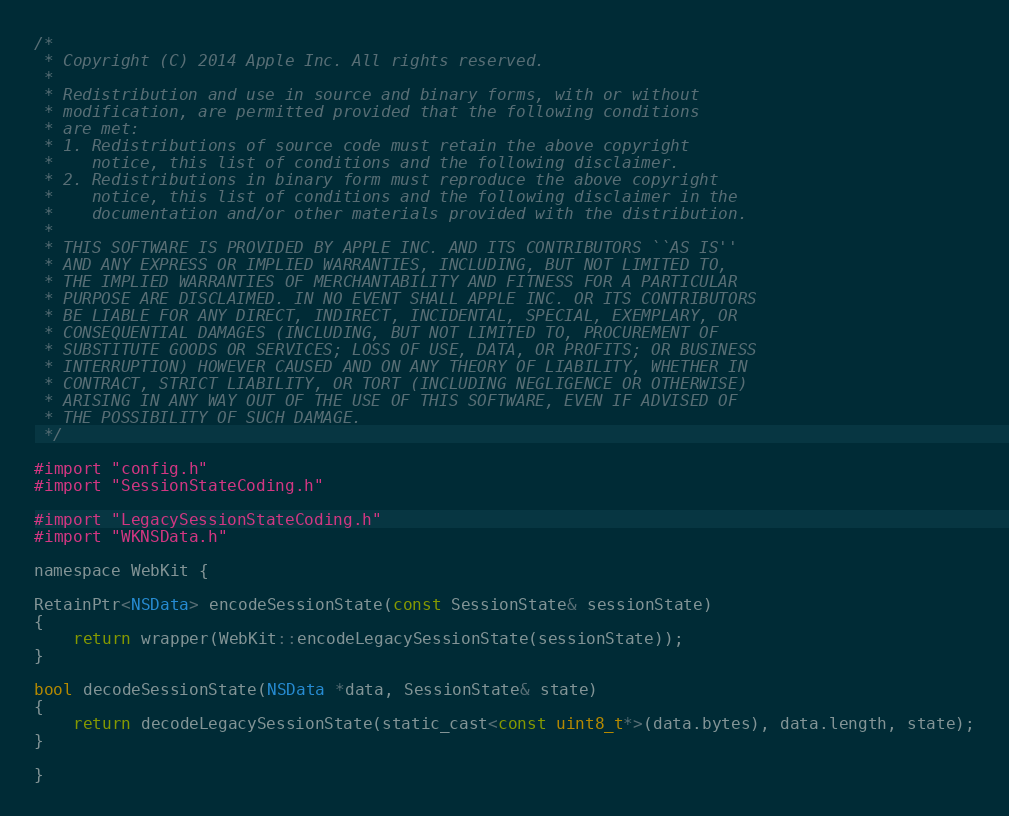Convert code to text. <code><loc_0><loc_0><loc_500><loc_500><_ObjectiveC_>/*
 * Copyright (C) 2014 Apple Inc. All rights reserved.
 *
 * Redistribution and use in source and binary forms, with or without
 * modification, are permitted provided that the following conditions
 * are met:
 * 1. Redistributions of source code must retain the above copyright
 *    notice, this list of conditions and the following disclaimer.
 * 2. Redistributions in binary form must reproduce the above copyright
 *    notice, this list of conditions and the following disclaimer in the
 *    documentation and/or other materials provided with the distribution.
 *
 * THIS SOFTWARE IS PROVIDED BY APPLE INC. AND ITS CONTRIBUTORS ``AS IS''
 * AND ANY EXPRESS OR IMPLIED WARRANTIES, INCLUDING, BUT NOT LIMITED TO,
 * THE IMPLIED WARRANTIES OF MERCHANTABILITY AND FITNESS FOR A PARTICULAR
 * PURPOSE ARE DISCLAIMED. IN NO EVENT SHALL APPLE INC. OR ITS CONTRIBUTORS
 * BE LIABLE FOR ANY DIRECT, INDIRECT, INCIDENTAL, SPECIAL, EXEMPLARY, OR
 * CONSEQUENTIAL DAMAGES (INCLUDING, BUT NOT LIMITED TO, PROCUREMENT OF
 * SUBSTITUTE GOODS OR SERVICES; LOSS OF USE, DATA, OR PROFITS; OR BUSINESS
 * INTERRUPTION) HOWEVER CAUSED AND ON ANY THEORY OF LIABILITY, WHETHER IN
 * CONTRACT, STRICT LIABILITY, OR TORT (INCLUDING NEGLIGENCE OR OTHERWISE)
 * ARISING IN ANY WAY OUT OF THE USE OF THIS SOFTWARE, EVEN IF ADVISED OF
 * THE POSSIBILITY OF SUCH DAMAGE.
 */

#import "config.h"
#import "SessionStateCoding.h"

#import "LegacySessionStateCoding.h"
#import "WKNSData.h"

namespace WebKit {

RetainPtr<NSData> encodeSessionState(const SessionState& sessionState)
{
    return wrapper(WebKit::encodeLegacySessionState(sessionState));
}

bool decodeSessionState(NSData *data, SessionState& state)
{
    return decodeLegacySessionState(static_cast<const uint8_t*>(data.bytes), data.length, state);
}

}
</code> 